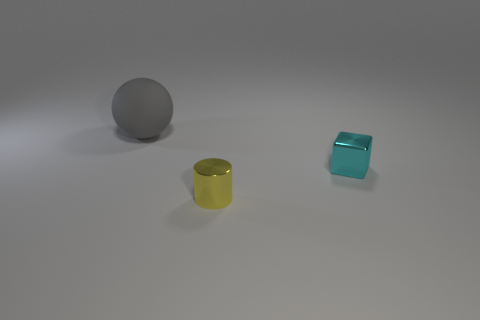Is there anything else that has the same size as the gray sphere?
Provide a succinct answer. No. There is a object that is made of the same material as the cylinder; what color is it?
Provide a short and direct response. Cyan. The small metallic thing that is behind the small object that is left of the small metallic object that is behind the small yellow cylinder is what color?
Your answer should be compact. Cyan. There is a metal object to the right of the tiny metal cylinder; what is its size?
Give a very brief answer. Small. What material is the large gray object?
Offer a terse response. Rubber. Is the number of yellow cylinders that are behind the large gray rubber sphere less than the number of big matte objects that are on the left side of the cube?
Offer a very short reply. Yes. Are there any other things that are made of the same material as the gray sphere?
Keep it short and to the point. No. Do the large matte object and the cylinder have the same color?
Offer a very short reply. No. The yellow thing that is made of the same material as the tiny cube is what shape?
Provide a short and direct response. Cylinder. What is the shape of the metal thing behind the tiny thing that is in front of the cyan metal cube?
Make the answer very short. Cube. 